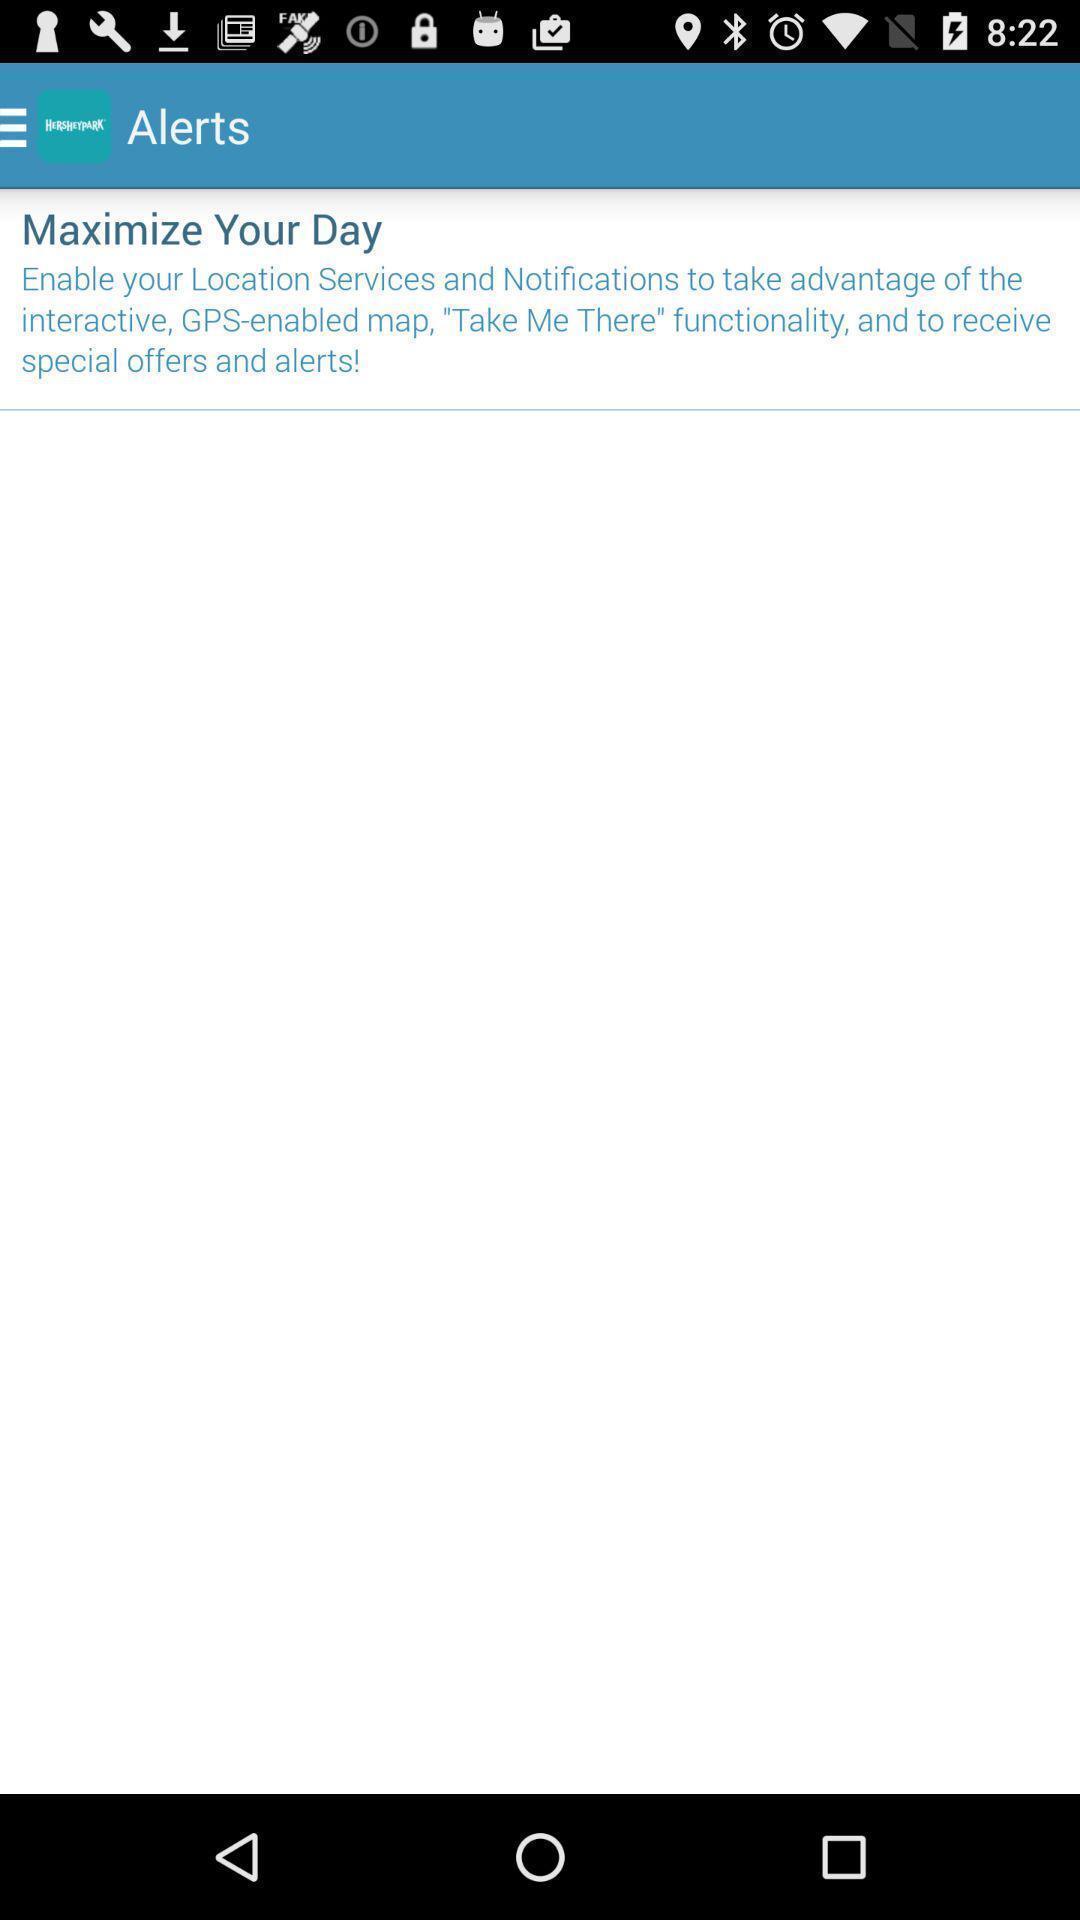Explain what's happening in this screen capture. Screen displaying the alerts page. 